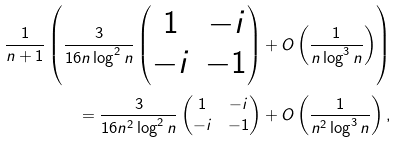<formula> <loc_0><loc_0><loc_500><loc_500>\frac { 1 } { n + 1 } \left ( \frac { 3 } { 1 6 n \log ^ { 2 } n } \left ( \begin{matrix} 1 & - i \\ - i & - 1 \end{matrix} \right ) + O \left ( \frac { 1 } { n \log ^ { 3 } n } \right ) \right ) \\ = \frac { 3 } { 1 6 n ^ { 2 } \log ^ { 2 } n } \left ( \begin{matrix} 1 & - i \\ - i & - 1 \end{matrix} \right ) + O \left ( \frac { 1 } { n ^ { 2 } \log ^ { 3 } n } \right ) ,</formula> 